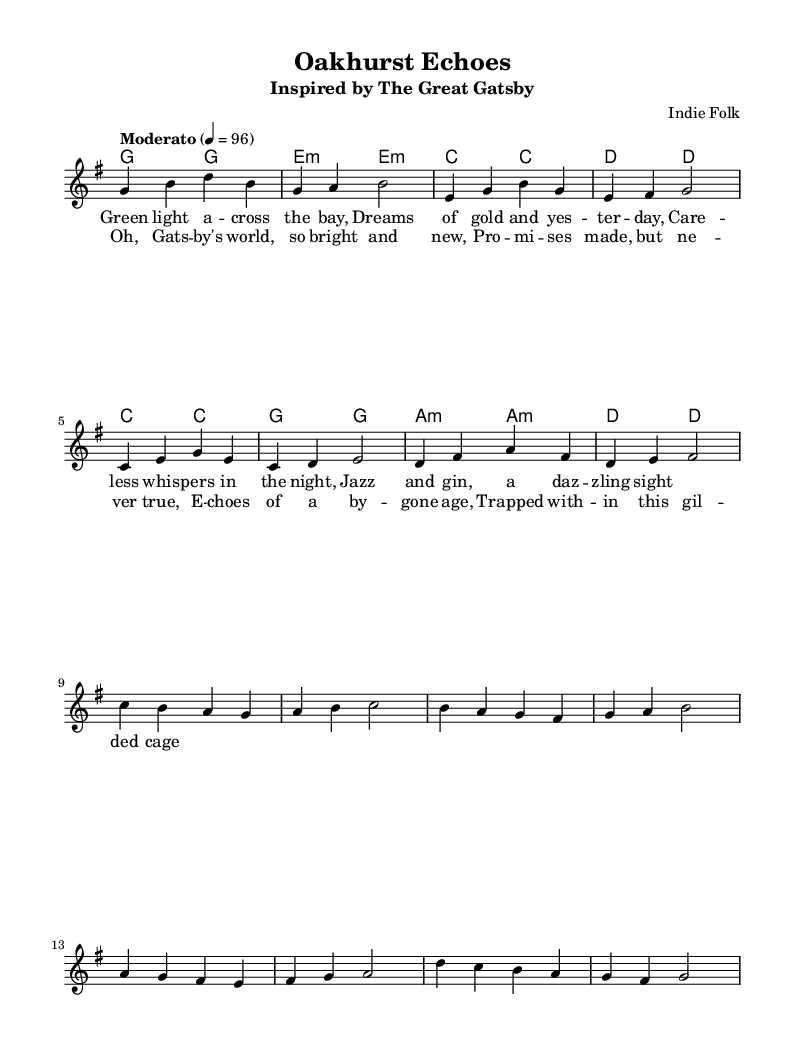What is the key signature of this music? The key signature is G major, which has one sharp. This can be identified by looking at the symbol located at the beginning of the staff right after the clef sign.
Answer: G major What is the time signature of this music? The time signature is 4/4, which indicates there are four beats in each measure. This is visible at the beginning of the sheet music, following the key signature.
Answer: 4/4 What is the tempo marking of the music? The tempo marking is "Moderato," which means moderate speed. This is indicated at the beginning of the score, along with the beats per minute.
Answer: Moderato How many measures are there in the verse? There are eight measures in the verse section. This can be determined by counting the measures that are marked in the melody part above the lyrics for the verse.
Answer: Eight What is the lyric associated with the chorus's first measure? The lyric associated with the first measure of the chorus is "Oh." This can be found directly under the melody notes that correspond to the first measure of the chorus.
Answer: Oh What type of musical piece is "Oakhurst Echoes"? "Oakhurst Echoes" is an indie folk song. This is evident from the header that describes the piece and its style as inspired by classic literature.
Answer: Indie folk What themes are echoed in the lyrics of the song? The themes echoed in the lyrics include dreams and nostalgia, specifically referencing "The Great Gatsby." This can be inferred from the context of the lyrics that mention dreams, the past, and aspirations.
Answer: Dreams and nostalgia 